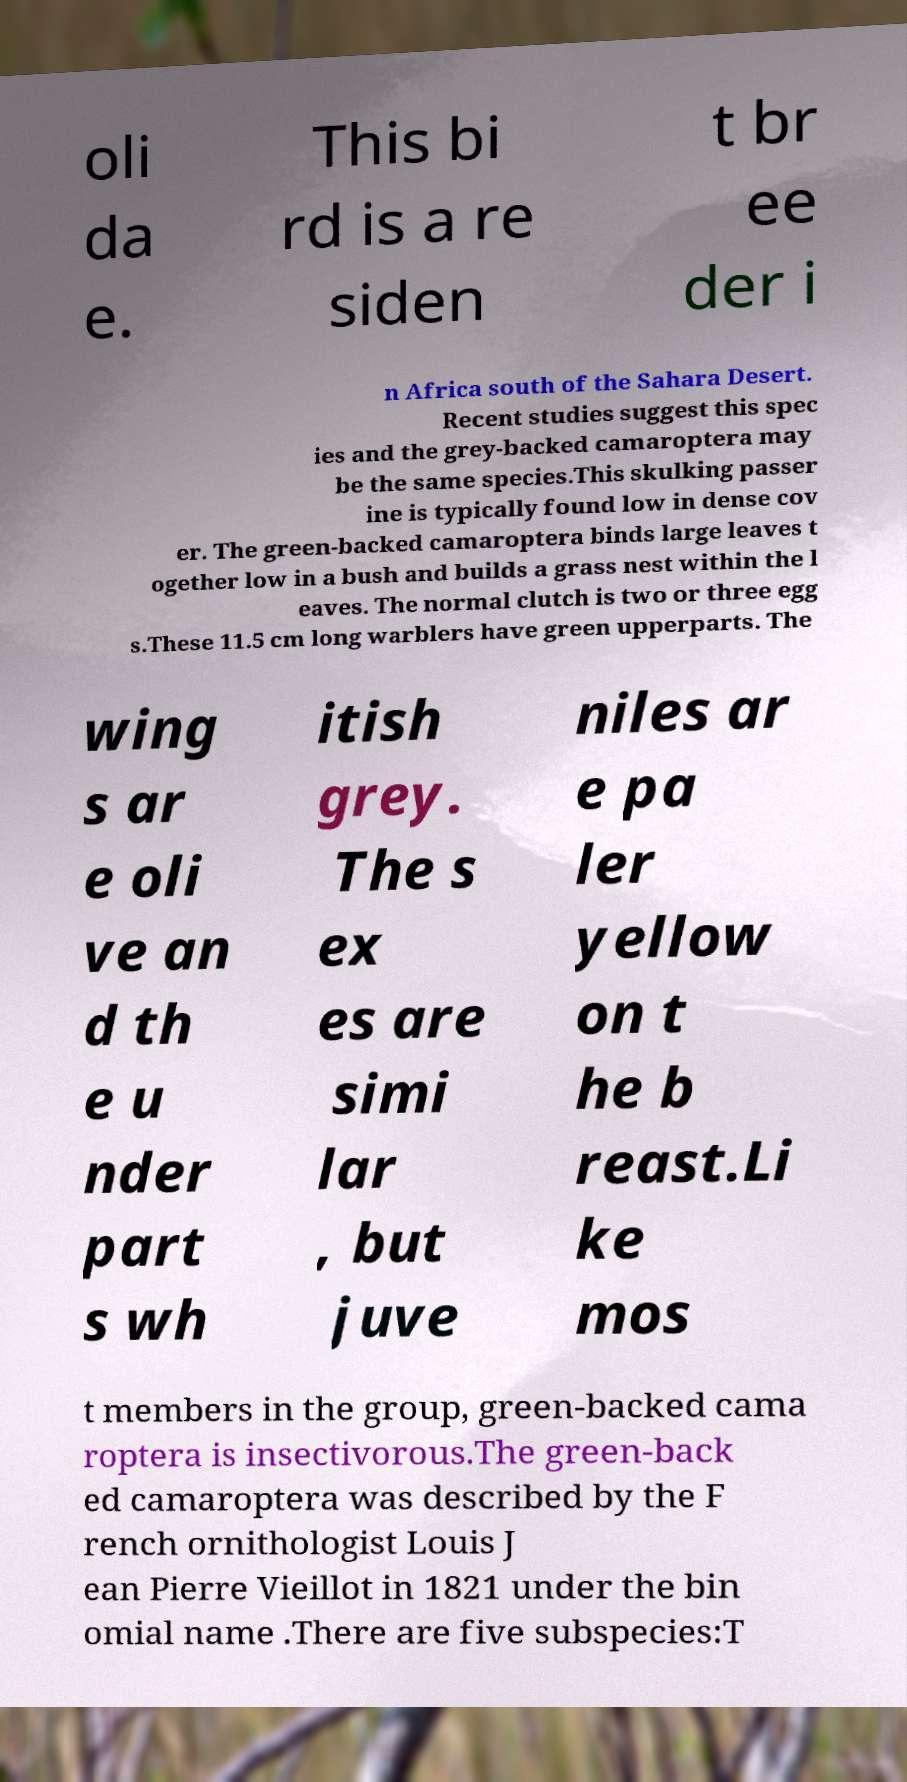There's text embedded in this image that I need extracted. Can you transcribe it verbatim? oli da e. This bi rd is a re siden t br ee der i n Africa south of the Sahara Desert. Recent studies suggest this spec ies and the grey-backed camaroptera may be the same species.This skulking passer ine is typically found low in dense cov er. The green-backed camaroptera binds large leaves t ogether low in a bush and builds a grass nest within the l eaves. The normal clutch is two or three egg s.These 11.5 cm long warblers have green upperparts. The wing s ar e oli ve an d th e u nder part s wh itish grey. The s ex es are simi lar , but juve niles ar e pa ler yellow on t he b reast.Li ke mos t members in the group, green-backed cama roptera is insectivorous.The green-back ed camaroptera was described by the F rench ornithologist Louis J ean Pierre Vieillot in 1821 under the bin omial name .There are five subspecies:T 